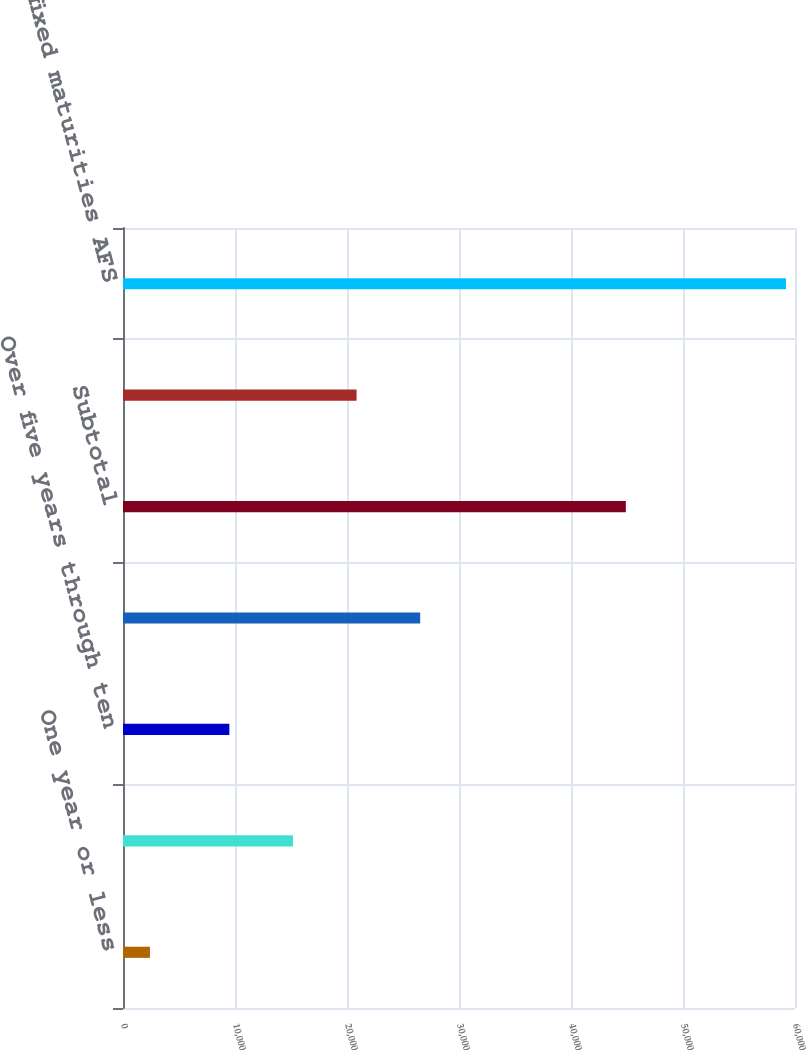Convert chart to OTSL. <chart><loc_0><loc_0><loc_500><loc_500><bar_chart><fcel>One year or less<fcel>Over one year through five<fcel>Over five years through ten<fcel>Over ten years<fcel>Subtotal<fcel>Mortgage-backed and<fcel>Total fixed maturities AFS<nl><fcel>2405<fcel>15176.1<fcel>9497<fcel>26534.3<fcel>44896<fcel>20855.2<fcel>59196<nl></chart> 